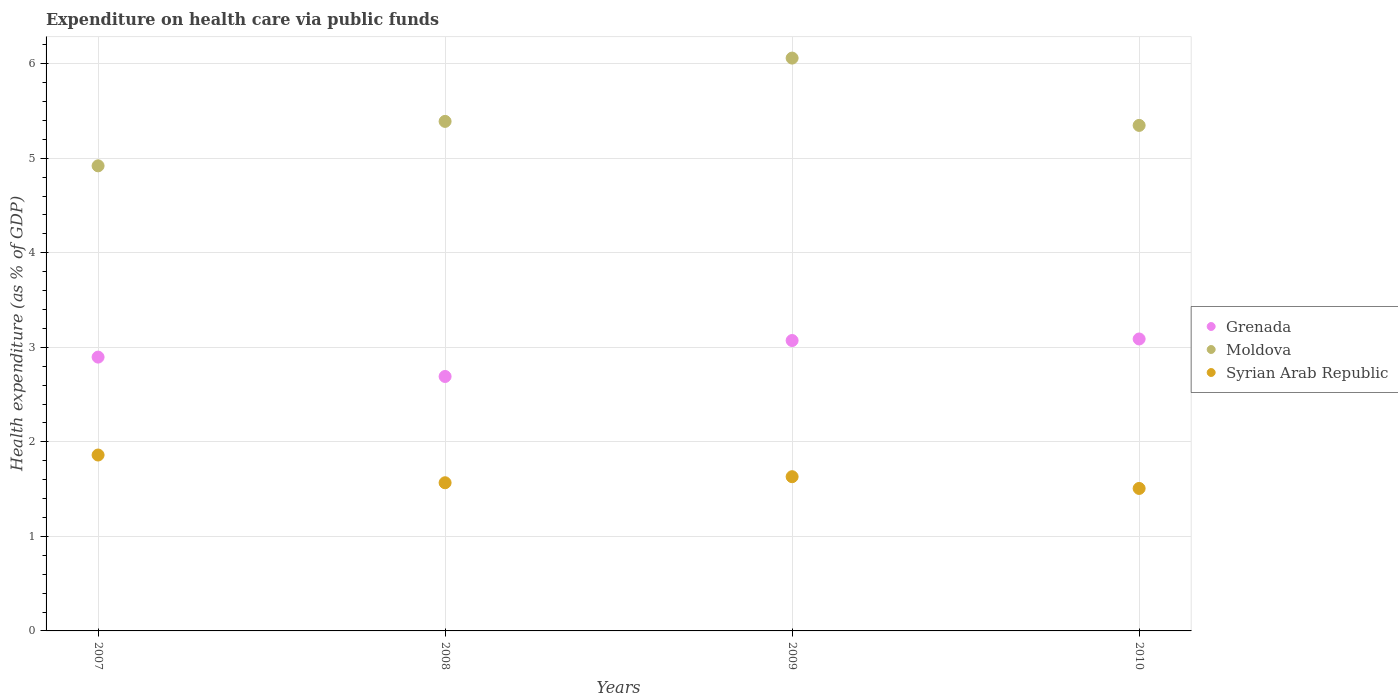How many different coloured dotlines are there?
Keep it short and to the point. 3. What is the expenditure made on health care in Moldova in 2008?
Keep it short and to the point. 5.39. Across all years, what is the maximum expenditure made on health care in Moldova?
Your response must be concise. 6.06. Across all years, what is the minimum expenditure made on health care in Grenada?
Give a very brief answer. 2.69. In which year was the expenditure made on health care in Moldova maximum?
Provide a short and direct response. 2009. In which year was the expenditure made on health care in Grenada minimum?
Provide a succinct answer. 2008. What is the total expenditure made on health care in Syrian Arab Republic in the graph?
Provide a succinct answer. 6.57. What is the difference between the expenditure made on health care in Grenada in 2007 and that in 2010?
Offer a terse response. -0.19. What is the difference between the expenditure made on health care in Grenada in 2008 and the expenditure made on health care in Moldova in 2007?
Keep it short and to the point. -2.23. What is the average expenditure made on health care in Syrian Arab Republic per year?
Your answer should be very brief. 1.64. In the year 2009, what is the difference between the expenditure made on health care in Syrian Arab Republic and expenditure made on health care in Moldova?
Provide a succinct answer. -4.43. In how many years, is the expenditure made on health care in Syrian Arab Republic greater than 1.4 %?
Your response must be concise. 4. What is the ratio of the expenditure made on health care in Syrian Arab Republic in 2007 to that in 2010?
Keep it short and to the point. 1.23. Is the expenditure made on health care in Moldova in 2007 less than that in 2009?
Your answer should be very brief. Yes. Is the difference between the expenditure made on health care in Syrian Arab Republic in 2007 and 2009 greater than the difference between the expenditure made on health care in Moldova in 2007 and 2009?
Make the answer very short. Yes. What is the difference between the highest and the second highest expenditure made on health care in Syrian Arab Republic?
Offer a terse response. 0.23. What is the difference between the highest and the lowest expenditure made on health care in Grenada?
Offer a terse response. 0.4. Is it the case that in every year, the sum of the expenditure made on health care in Syrian Arab Republic and expenditure made on health care in Moldova  is greater than the expenditure made on health care in Grenada?
Ensure brevity in your answer.  Yes. Does the expenditure made on health care in Syrian Arab Republic monotonically increase over the years?
Your answer should be very brief. No. How many years are there in the graph?
Keep it short and to the point. 4. What is the difference between two consecutive major ticks on the Y-axis?
Your response must be concise. 1. Does the graph contain grids?
Your answer should be compact. Yes. Where does the legend appear in the graph?
Give a very brief answer. Center right. How many legend labels are there?
Offer a terse response. 3. How are the legend labels stacked?
Offer a terse response. Vertical. What is the title of the graph?
Offer a very short reply. Expenditure on health care via public funds. What is the label or title of the Y-axis?
Ensure brevity in your answer.  Health expenditure (as % of GDP). What is the Health expenditure (as % of GDP) in Grenada in 2007?
Offer a terse response. 2.9. What is the Health expenditure (as % of GDP) in Moldova in 2007?
Make the answer very short. 4.92. What is the Health expenditure (as % of GDP) of Syrian Arab Republic in 2007?
Your answer should be very brief. 1.86. What is the Health expenditure (as % of GDP) of Grenada in 2008?
Provide a short and direct response. 2.69. What is the Health expenditure (as % of GDP) in Moldova in 2008?
Keep it short and to the point. 5.39. What is the Health expenditure (as % of GDP) in Syrian Arab Republic in 2008?
Ensure brevity in your answer.  1.57. What is the Health expenditure (as % of GDP) of Grenada in 2009?
Make the answer very short. 3.07. What is the Health expenditure (as % of GDP) in Moldova in 2009?
Provide a short and direct response. 6.06. What is the Health expenditure (as % of GDP) of Syrian Arab Republic in 2009?
Your answer should be very brief. 1.63. What is the Health expenditure (as % of GDP) of Grenada in 2010?
Offer a terse response. 3.09. What is the Health expenditure (as % of GDP) in Moldova in 2010?
Offer a terse response. 5.35. What is the Health expenditure (as % of GDP) in Syrian Arab Republic in 2010?
Give a very brief answer. 1.51. Across all years, what is the maximum Health expenditure (as % of GDP) in Grenada?
Provide a succinct answer. 3.09. Across all years, what is the maximum Health expenditure (as % of GDP) in Moldova?
Provide a short and direct response. 6.06. Across all years, what is the maximum Health expenditure (as % of GDP) in Syrian Arab Republic?
Your response must be concise. 1.86. Across all years, what is the minimum Health expenditure (as % of GDP) in Grenada?
Ensure brevity in your answer.  2.69. Across all years, what is the minimum Health expenditure (as % of GDP) of Moldova?
Keep it short and to the point. 4.92. Across all years, what is the minimum Health expenditure (as % of GDP) in Syrian Arab Republic?
Provide a succinct answer. 1.51. What is the total Health expenditure (as % of GDP) of Grenada in the graph?
Ensure brevity in your answer.  11.75. What is the total Health expenditure (as % of GDP) of Moldova in the graph?
Give a very brief answer. 21.72. What is the total Health expenditure (as % of GDP) in Syrian Arab Republic in the graph?
Offer a very short reply. 6.57. What is the difference between the Health expenditure (as % of GDP) in Grenada in 2007 and that in 2008?
Provide a short and direct response. 0.2. What is the difference between the Health expenditure (as % of GDP) of Moldova in 2007 and that in 2008?
Your answer should be compact. -0.47. What is the difference between the Health expenditure (as % of GDP) in Syrian Arab Republic in 2007 and that in 2008?
Ensure brevity in your answer.  0.29. What is the difference between the Health expenditure (as % of GDP) of Grenada in 2007 and that in 2009?
Your response must be concise. -0.18. What is the difference between the Health expenditure (as % of GDP) of Moldova in 2007 and that in 2009?
Provide a succinct answer. -1.14. What is the difference between the Health expenditure (as % of GDP) in Syrian Arab Republic in 2007 and that in 2009?
Your answer should be compact. 0.23. What is the difference between the Health expenditure (as % of GDP) in Grenada in 2007 and that in 2010?
Your answer should be compact. -0.19. What is the difference between the Health expenditure (as % of GDP) in Moldova in 2007 and that in 2010?
Provide a short and direct response. -0.43. What is the difference between the Health expenditure (as % of GDP) of Syrian Arab Republic in 2007 and that in 2010?
Your answer should be compact. 0.35. What is the difference between the Health expenditure (as % of GDP) of Grenada in 2008 and that in 2009?
Provide a succinct answer. -0.38. What is the difference between the Health expenditure (as % of GDP) in Moldova in 2008 and that in 2009?
Offer a very short reply. -0.67. What is the difference between the Health expenditure (as % of GDP) in Syrian Arab Republic in 2008 and that in 2009?
Give a very brief answer. -0.06. What is the difference between the Health expenditure (as % of GDP) in Grenada in 2008 and that in 2010?
Make the answer very short. -0.4. What is the difference between the Health expenditure (as % of GDP) in Moldova in 2008 and that in 2010?
Offer a very short reply. 0.04. What is the difference between the Health expenditure (as % of GDP) in Syrian Arab Republic in 2008 and that in 2010?
Offer a terse response. 0.06. What is the difference between the Health expenditure (as % of GDP) of Grenada in 2009 and that in 2010?
Keep it short and to the point. -0.02. What is the difference between the Health expenditure (as % of GDP) in Moldova in 2009 and that in 2010?
Give a very brief answer. 0.71. What is the difference between the Health expenditure (as % of GDP) in Syrian Arab Republic in 2009 and that in 2010?
Make the answer very short. 0.12. What is the difference between the Health expenditure (as % of GDP) in Grenada in 2007 and the Health expenditure (as % of GDP) in Moldova in 2008?
Your answer should be compact. -2.49. What is the difference between the Health expenditure (as % of GDP) in Grenada in 2007 and the Health expenditure (as % of GDP) in Syrian Arab Republic in 2008?
Keep it short and to the point. 1.33. What is the difference between the Health expenditure (as % of GDP) in Moldova in 2007 and the Health expenditure (as % of GDP) in Syrian Arab Republic in 2008?
Offer a terse response. 3.35. What is the difference between the Health expenditure (as % of GDP) in Grenada in 2007 and the Health expenditure (as % of GDP) in Moldova in 2009?
Provide a succinct answer. -3.16. What is the difference between the Health expenditure (as % of GDP) of Grenada in 2007 and the Health expenditure (as % of GDP) of Syrian Arab Republic in 2009?
Ensure brevity in your answer.  1.27. What is the difference between the Health expenditure (as % of GDP) of Moldova in 2007 and the Health expenditure (as % of GDP) of Syrian Arab Republic in 2009?
Keep it short and to the point. 3.29. What is the difference between the Health expenditure (as % of GDP) of Grenada in 2007 and the Health expenditure (as % of GDP) of Moldova in 2010?
Keep it short and to the point. -2.45. What is the difference between the Health expenditure (as % of GDP) of Grenada in 2007 and the Health expenditure (as % of GDP) of Syrian Arab Republic in 2010?
Ensure brevity in your answer.  1.39. What is the difference between the Health expenditure (as % of GDP) in Moldova in 2007 and the Health expenditure (as % of GDP) in Syrian Arab Republic in 2010?
Your response must be concise. 3.41. What is the difference between the Health expenditure (as % of GDP) in Grenada in 2008 and the Health expenditure (as % of GDP) in Moldova in 2009?
Your answer should be very brief. -3.37. What is the difference between the Health expenditure (as % of GDP) of Grenada in 2008 and the Health expenditure (as % of GDP) of Syrian Arab Republic in 2009?
Keep it short and to the point. 1.06. What is the difference between the Health expenditure (as % of GDP) of Moldova in 2008 and the Health expenditure (as % of GDP) of Syrian Arab Republic in 2009?
Your answer should be very brief. 3.76. What is the difference between the Health expenditure (as % of GDP) of Grenada in 2008 and the Health expenditure (as % of GDP) of Moldova in 2010?
Provide a succinct answer. -2.66. What is the difference between the Health expenditure (as % of GDP) in Grenada in 2008 and the Health expenditure (as % of GDP) in Syrian Arab Republic in 2010?
Give a very brief answer. 1.18. What is the difference between the Health expenditure (as % of GDP) in Moldova in 2008 and the Health expenditure (as % of GDP) in Syrian Arab Republic in 2010?
Provide a short and direct response. 3.88. What is the difference between the Health expenditure (as % of GDP) in Grenada in 2009 and the Health expenditure (as % of GDP) in Moldova in 2010?
Keep it short and to the point. -2.28. What is the difference between the Health expenditure (as % of GDP) in Grenada in 2009 and the Health expenditure (as % of GDP) in Syrian Arab Republic in 2010?
Your answer should be compact. 1.56. What is the difference between the Health expenditure (as % of GDP) of Moldova in 2009 and the Health expenditure (as % of GDP) of Syrian Arab Republic in 2010?
Provide a succinct answer. 4.55. What is the average Health expenditure (as % of GDP) in Grenada per year?
Your answer should be compact. 2.94. What is the average Health expenditure (as % of GDP) of Moldova per year?
Your response must be concise. 5.43. What is the average Health expenditure (as % of GDP) in Syrian Arab Republic per year?
Keep it short and to the point. 1.64. In the year 2007, what is the difference between the Health expenditure (as % of GDP) of Grenada and Health expenditure (as % of GDP) of Moldova?
Keep it short and to the point. -2.02. In the year 2007, what is the difference between the Health expenditure (as % of GDP) of Grenada and Health expenditure (as % of GDP) of Syrian Arab Republic?
Provide a succinct answer. 1.04. In the year 2007, what is the difference between the Health expenditure (as % of GDP) of Moldova and Health expenditure (as % of GDP) of Syrian Arab Republic?
Keep it short and to the point. 3.06. In the year 2008, what is the difference between the Health expenditure (as % of GDP) in Grenada and Health expenditure (as % of GDP) in Moldova?
Your answer should be compact. -2.7. In the year 2008, what is the difference between the Health expenditure (as % of GDP) of Grenada and Health expenditure (as % of GDP) of Syrian Arab Republic?
Provide a succinct answer. 1.12. In the year 2008, what is the difference between the Health expenditure (as % of GDP) of Moldova and Health expenditure (as % of GDP) of Syrian Arab Republic?
Provide a succinct answer. 3.82. In the year 2009, what is the difference between the Health expenditure (as % of GDP) in Grenada and Health expenditure (as % of GDP) in Moldova?
Your answer should be very brief. -2.99. In the year 2009, what is the difference between the Health expenditure (as % of GDP) of Grenada and Health expenditure (as % of GDP) of Syrian Arab Republic?
Offer a terse response. 1.44. In the year 2009, what is the difference between the Health expenditure (as % of GDP) of Moldova and Health expenditure (as % of GDP) of Syrian Arab Republic?
Offer a terse response. 4.43. In the year 2010, what is the difference between the Health expenditure (as % of GDP) of Grenada and Health expenditure (as % of GDP) of Moldova?
Offer a very short reply. -2.26. In the year 2010, what is the difference between the Health expenditure (as % of GDP) in Grenada and Health expenditure (as % of GDP) in Syrian Arab Republic?
Your response must be concise. 1.58. In the year 2010, what is the difference between the Health expenditure (as % of GDP) in Moldova and Health expenditure (as % of GDP) in Syrian Arab Republic?
Offer a very short reply. 3.84. What is the ratio of the Health expenditure (as % of GDP) in Grenada in 2007 to that in 2008?
Give a very brief answer. 1.08. What is the ratio of the Health expenditure (as % of GDP) of Moldova in 2007 to that in 2008?
Your response must be concise. 0.91. What is the ratio of the Health expenditure (as % of GDP) in Syrian Arab Republic in 2007 to that in 2008?
Provide a short and direct response. 1.19. What is the ratio of the Health expenditure (as % of GDP) of Grenada in 2007 to that in 2009?
Give a very brief answer. 0.94. What is the ratio of the Health expenditure (as % of GDP) of Moldova in 2007 to that in 2009?
Make the answer very short. 0.81. What is the ratio of the Health expenditure (as % of GDP) of Syrian Arab Republic in 2007 to that in 2009?
Your response must be concise. 1.14. What is the ratio of the Health expenditure (as % of GDP) in Grenada in 2007 to that in 2010?
Your response must be concise. 0.94. What is the ratio of the Health expenditure (as % of GDP) in Syrian Arab Republic in 2007 to that in 2010?
Your answer should be compact. 1.23. What is the ratio of the Health expenditure (as % of GDP) of Grenada in 2008 to that in 2009?
Your answer should be compact. 0.88. What is the ratio of the Health expenditure (as % of GDP) of Moldova in 2008 to that in 2009?
Provide a succinct answer. 0.89. What is the ratio of the Health expenditure (as % of GDP) in Syrian Arab Republic in 2008 to that in 2009?
Offer a terse response. 0.96. What is the ratio of the Health expenditure (as % of GDP) in Grenada in 2008 to that in 2010?
Provide a succinct answer. 0.87. What is the ratio of the Health expenditure (as % of GDP) of Moldova in 2008 to that in 2010?
Provide a succinct answer. 1.01. What is the ratio of the Health expenditure (as % of GDP) in Syrian Arab Republic in 2008 to that in 2010?
Provide a succinct answer. 1.04. What is the ratio of the Health expenditure (as % of GDP) of Moldova in 2009 to that in 2010?
Your answer should be very brief. 1.13. What is the ratio of the Health expenditure (as % of GDP) of Syrian Arab Republic in 2009 to that in 2010?
Keep it short and to the point. 1.08. What is the difference between the highest and the second highest Health expenditure (as % of GDP) of Grenada?
Your response must be concise. 0.02. What is the difference between the highest and the second highest Health expenditure (as % of GDP) of Moldova?
Offer a terse response. 0.67. What is the difference between the highest and the second highest Health expenditure (as % of GDP) in Syrian Arab Republic?
Make the answer very short. 0.23. What is the difference between the highest and the lowest Health expenditure (as % of GDP) of Grenada?
Your answer should be compact. 0.4. What is the difference between the highest and the lowest Health expenditure (as % of GDP) of Moldova?
Give a very brief answer. 1.14. What is the difference between the highest and the lowest Health expenditure (as % of GDP) in Syrian Arab Republic?
Your answer should be compact. 0.35. 